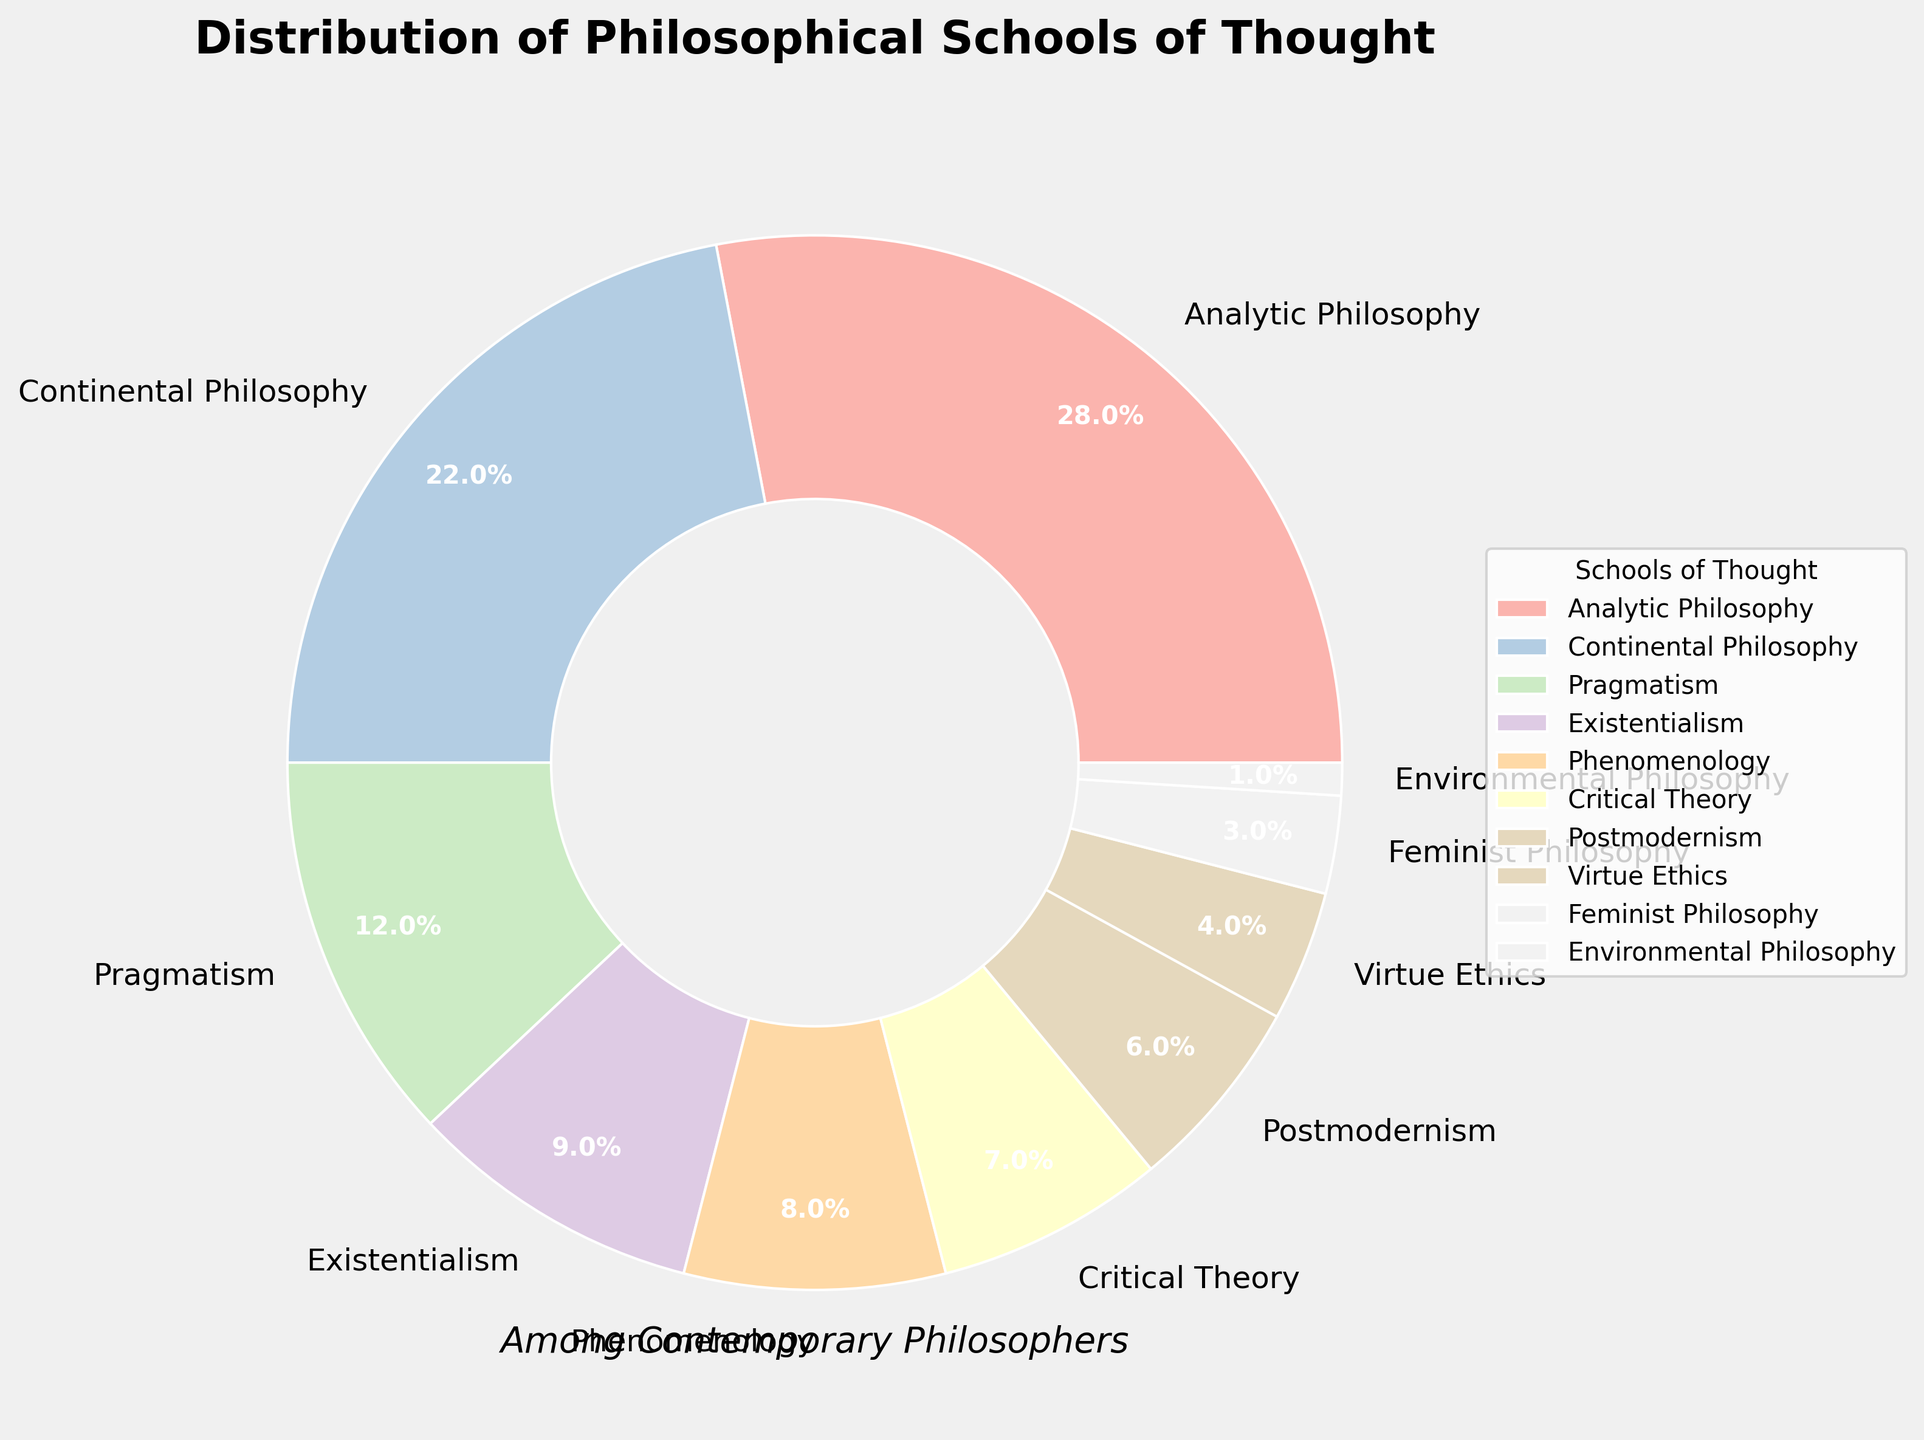Which philosophical school of thought has the highest percentage among contemporary philosophers? The slice representing "Analytic Philosophy" is the largest and shows 28%. Therefore, "Analytic Philosophy" has the highest percentage.
Answer: Analytic Philosophy How much more percentage does Analytic Philosophy have compared to Existentialism? Analytic Philosophy has 28% and Existentialism has 9%. The difference is 28% - 9% = 19%.
Answer: 19% What is the combined percentage of Continental Philosophy and Pragmatism? Continental Philosophy has 22% and Pragmatism has 12%. Summing them up gives 22% + 12% = 34%.
Answer: 34% Which school of thought has less representation than Phenomenology but more than Virtue Ethics? Phenomenology is at 8% and Virtue Ethics is at 4%. The school of thought with a percentage between these values is Critical Theory at 7%.
Answer: Critical Theory By how many percentage points does Pragmatism exceed the combined percentage of Feminist Philosophy and Environmental Philosophy? Pragmatism is at 12%, while Feminist Philosophy is at 3% and Environmental Philosophy is at 1%. The combined percentage of Feminist and Environmental Philosophy is 3% + 1% = 4%. The difference is 12% - 4% = 8%.
Answer: 8% What is the average percentage representation of Existentialism, Phenomenology, and Critical Theory? Existentialism is at 9%, Phenomenology at 8%, and Critical Theory at 7%. Their total is 9% + 8% + 7% = 24%, and the average is 24% / 3 = 8%.
Answer: 8% Which two schools of thought together account for more than 50% of the distribution? Analytic Philosophy (28%) and Continental Philosophy (22%) together sum to 28% + 22% = 50%.
Answer: Analytic Philosophy and Continental Philosophy Are there more schools of thought with a percentage below 10% or above 10%? Schools below 10%: Existentialism, Phenomenology, Critical Theory, Postmodernism, Virtue Ethics, Feminist Philosophy, Environmental Philosophy (7 schools). Schools above 10%: Analytic Philosophy, Continental Philosophy, and Pragmatism (3 schools). There are more with a percentage below 10%.
Answer: Below 10% 